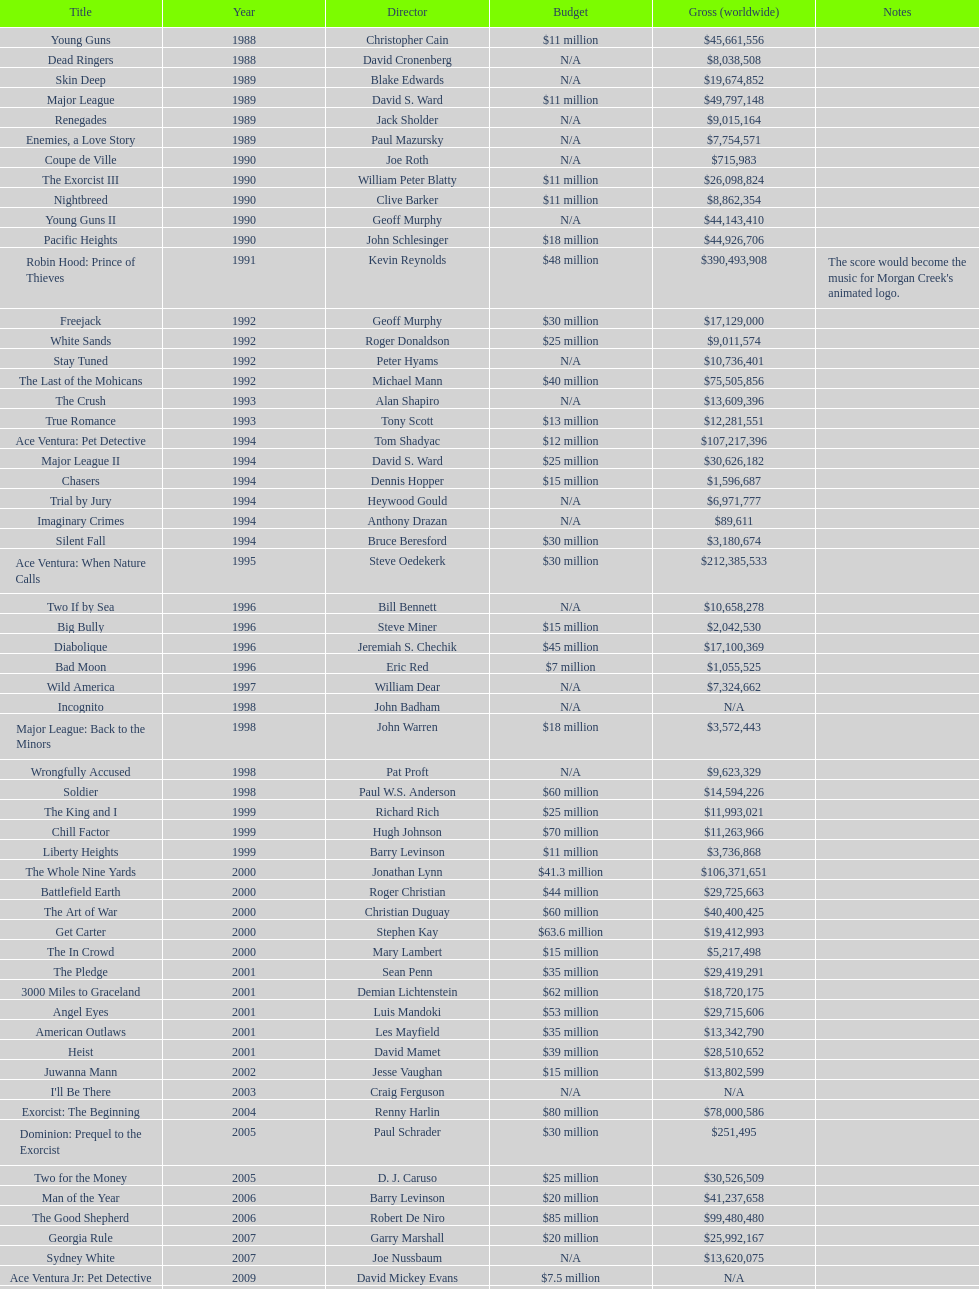Which film had a higher budget, ace ventura: when nature calls, or major league: back to the minors? Ace Ventura: When Nature Calls. 